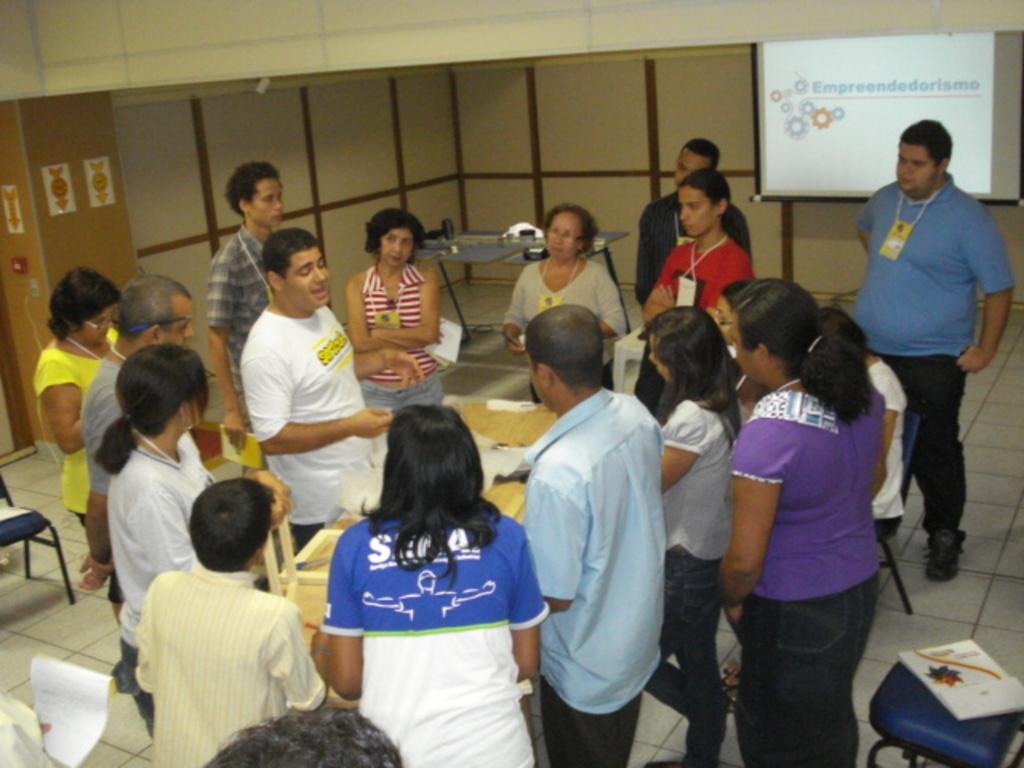What are the people in the image doing? The people are standing in front of a table. What can be seen on the table? There are objects on the table. What is located in the background of the image? There is a screen on a board and chairs visible in the background. What type of sweater is the person wearing in the image? There is no sweater visible in the image; the people are not wearing any clothing mentioned in the facts. 